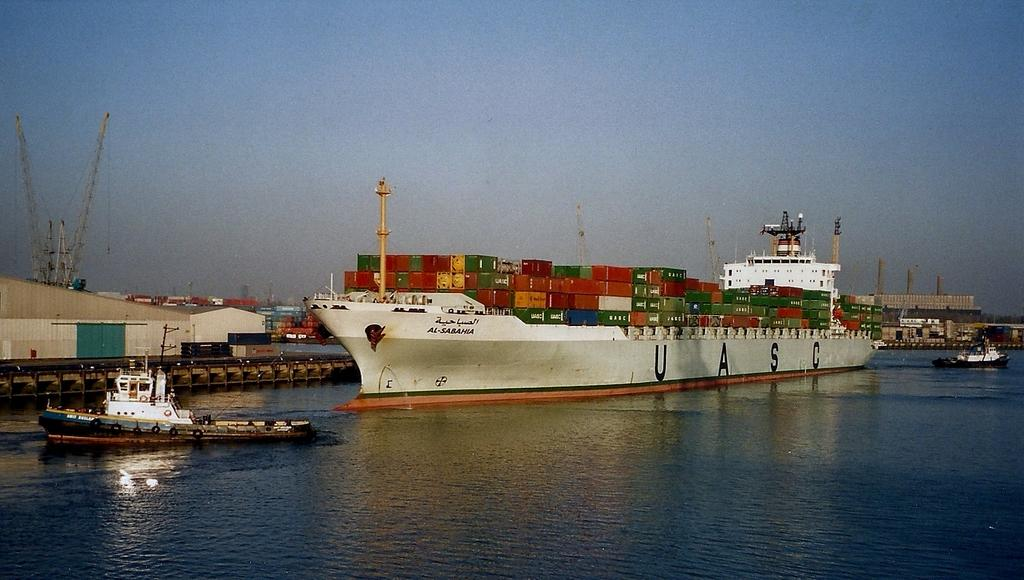What types of vehicles are in the image? There are boats and ships in the image. Where are the boats and ships located? The boats and ships are on the water. What can be found on one of the ships? There are containers on one of the ships. What can be seen in the background of the image? There are buildings and cranes in the background of the image. What is the color of the sky in the background of the image? The sky is blue in the background of the image. Reasoning: Let'g: Let's think step by step in order to produce the conversation. We start by identifying the main subjects in the image, which are the boats and ships. Then, we describe their location and the presence of containers on one of the ships. Next, we mention the background elements, including buildings and cranes. Finally, we note the color of the sky. Each question is designed to elicit a specific detail about the image that is known from the provided facts. Absurd Question/Answer: How does the ice compare to the size of the boats in the image? There is no ice present in the image, so it cannot be compared to the size of the boats. What type of beam is holding up the cranes in the image? There is no beam visible in the image; only the cranes are mentioned in the background. What type of beam is holding up the cranes in the image? There is no beam visible in the image; only the cranes are mentioned in the background. 